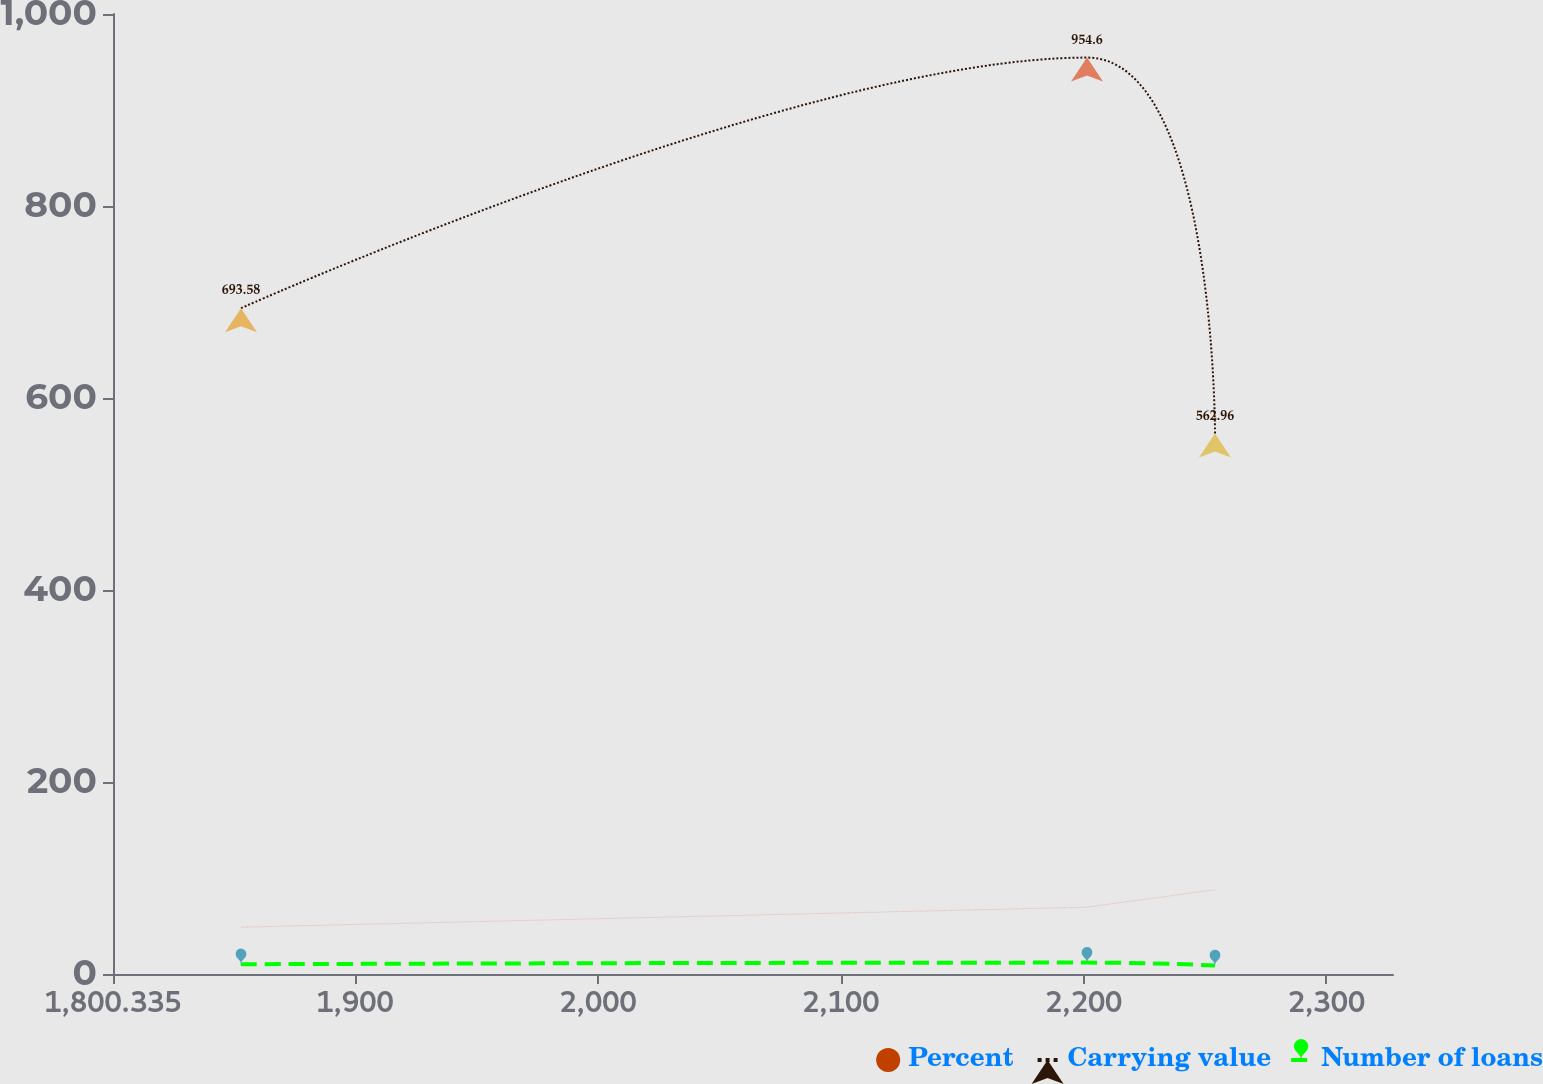Convert chart. <chart><loc_0><loc_0><loc_500><loc_500><line_chart><ecel><fcel>Percent<fcel>Carrying value<fcel>Number of loans<nl><fcel>1853.04<fcel>48.8<fcel>693.58<fcel>10.14<nl><fcel>2201.39<fcel>69.58<fcel>954.6<fcel>11.86<nl><fcel>2254.09<fcel>87.77<fcel>562.96<fcel>8.92<nl><fcel>2380.09<fcel>65.68<fcel>1190.1<fcel>17.5<nl></chart> 